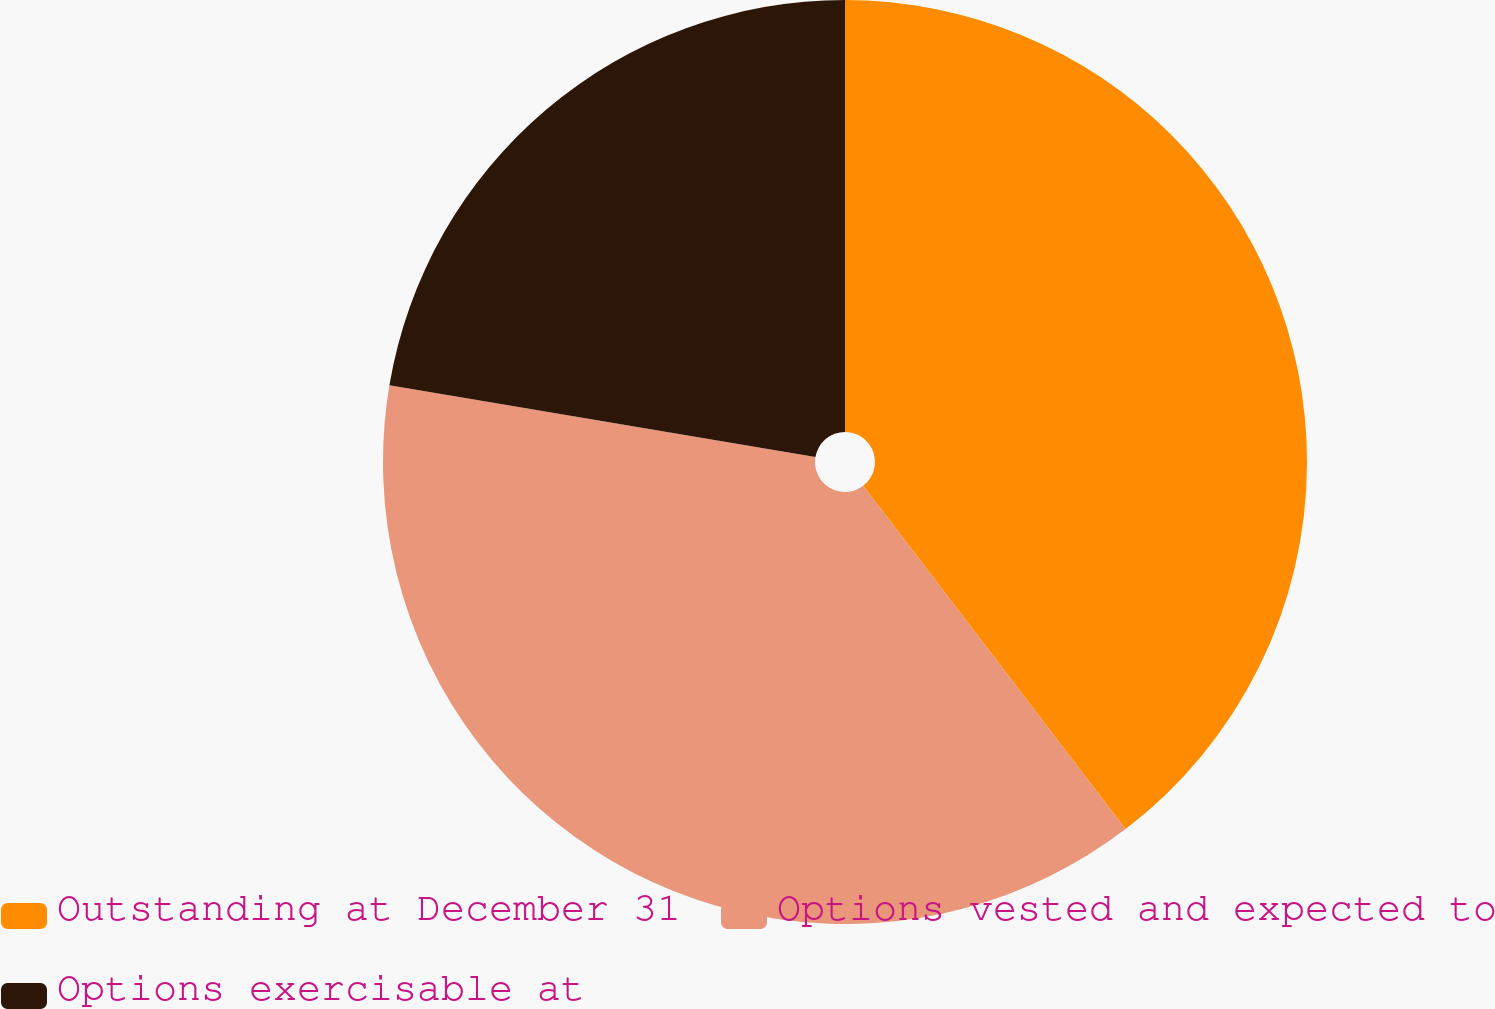Convert chart. <chart><loc_0><loc_0><loc_500><loc_500><pie_chart><fcel>Outstanding at December 31<fcel>Options vested and expected to<fcel>Options exercisable at<nl><fcel>39.62%<fcel>38.04%<fcel>22.35%<nl></chart> 